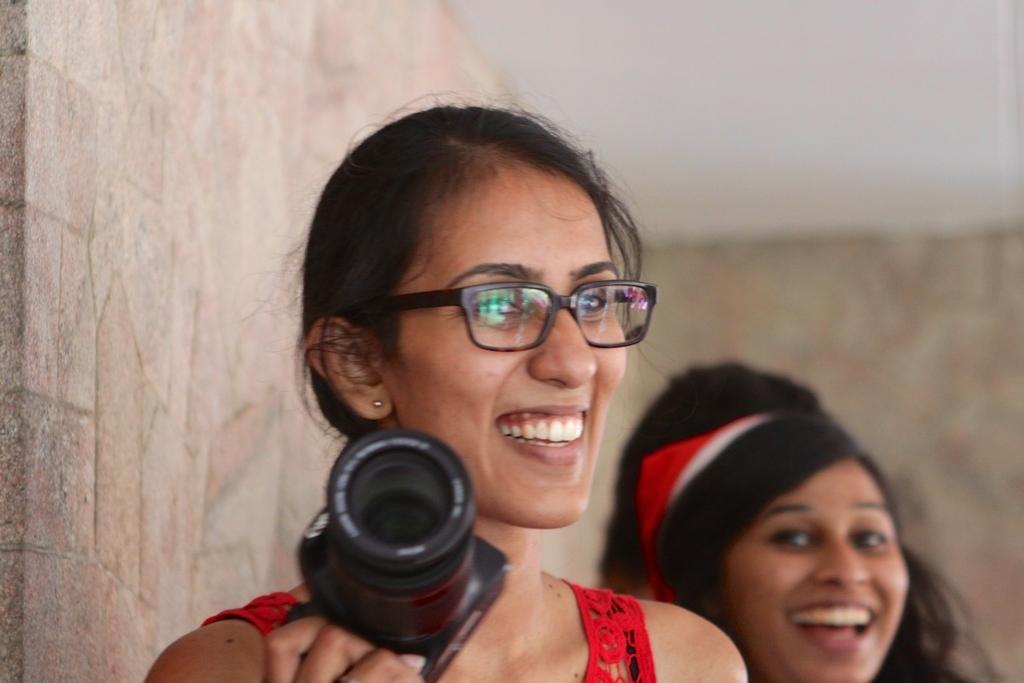Describe this image in one or two sentences. In the middle there is a woman she is smiling , she wear a red dress , she is holding a camera. To the right there is a woman ,she is smiling. In the background there is a wall , I think this is a house. 